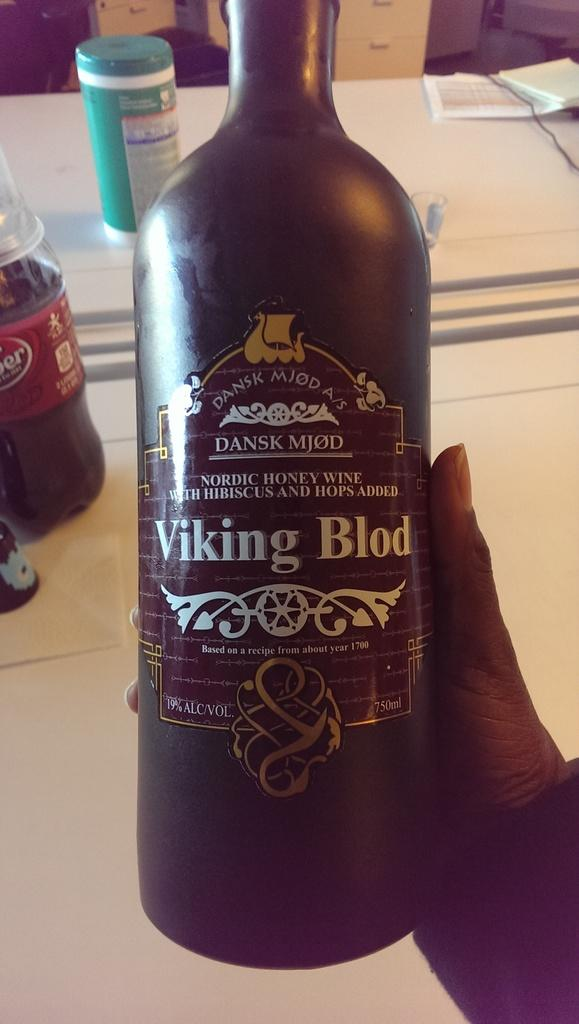<image>
Summarize the visual content of the image. A hand holding a black bottle of Viking blood branded wine. 